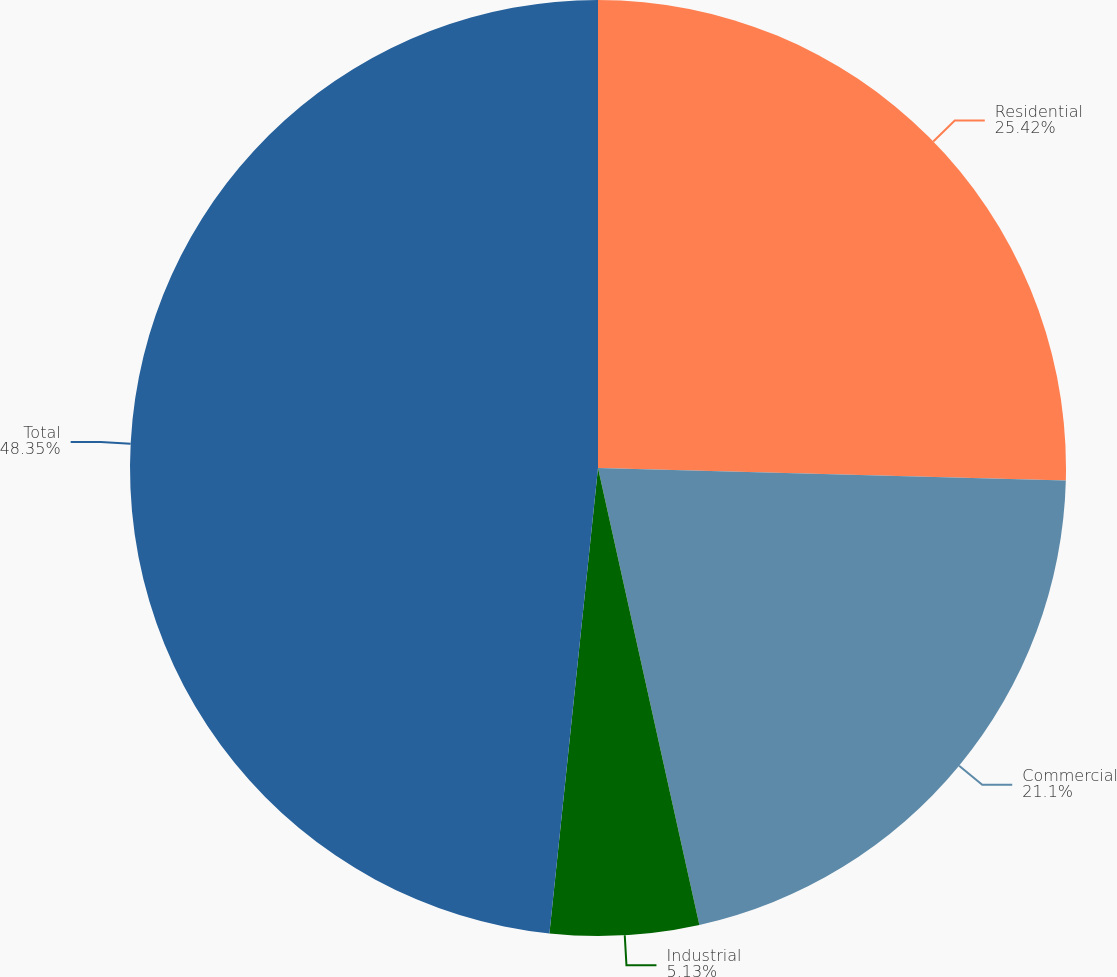Convert chart. <chart><loc_0><loc_0><loc_500><loc_500><pie_chart><fcel>Residential<fcel>Commercial<fcel>Industrial<fcel>Total<nl><fcel>25.42%<fcel>21.1%<fcel>5.13%<fcel>48.34%<nl></chart> 